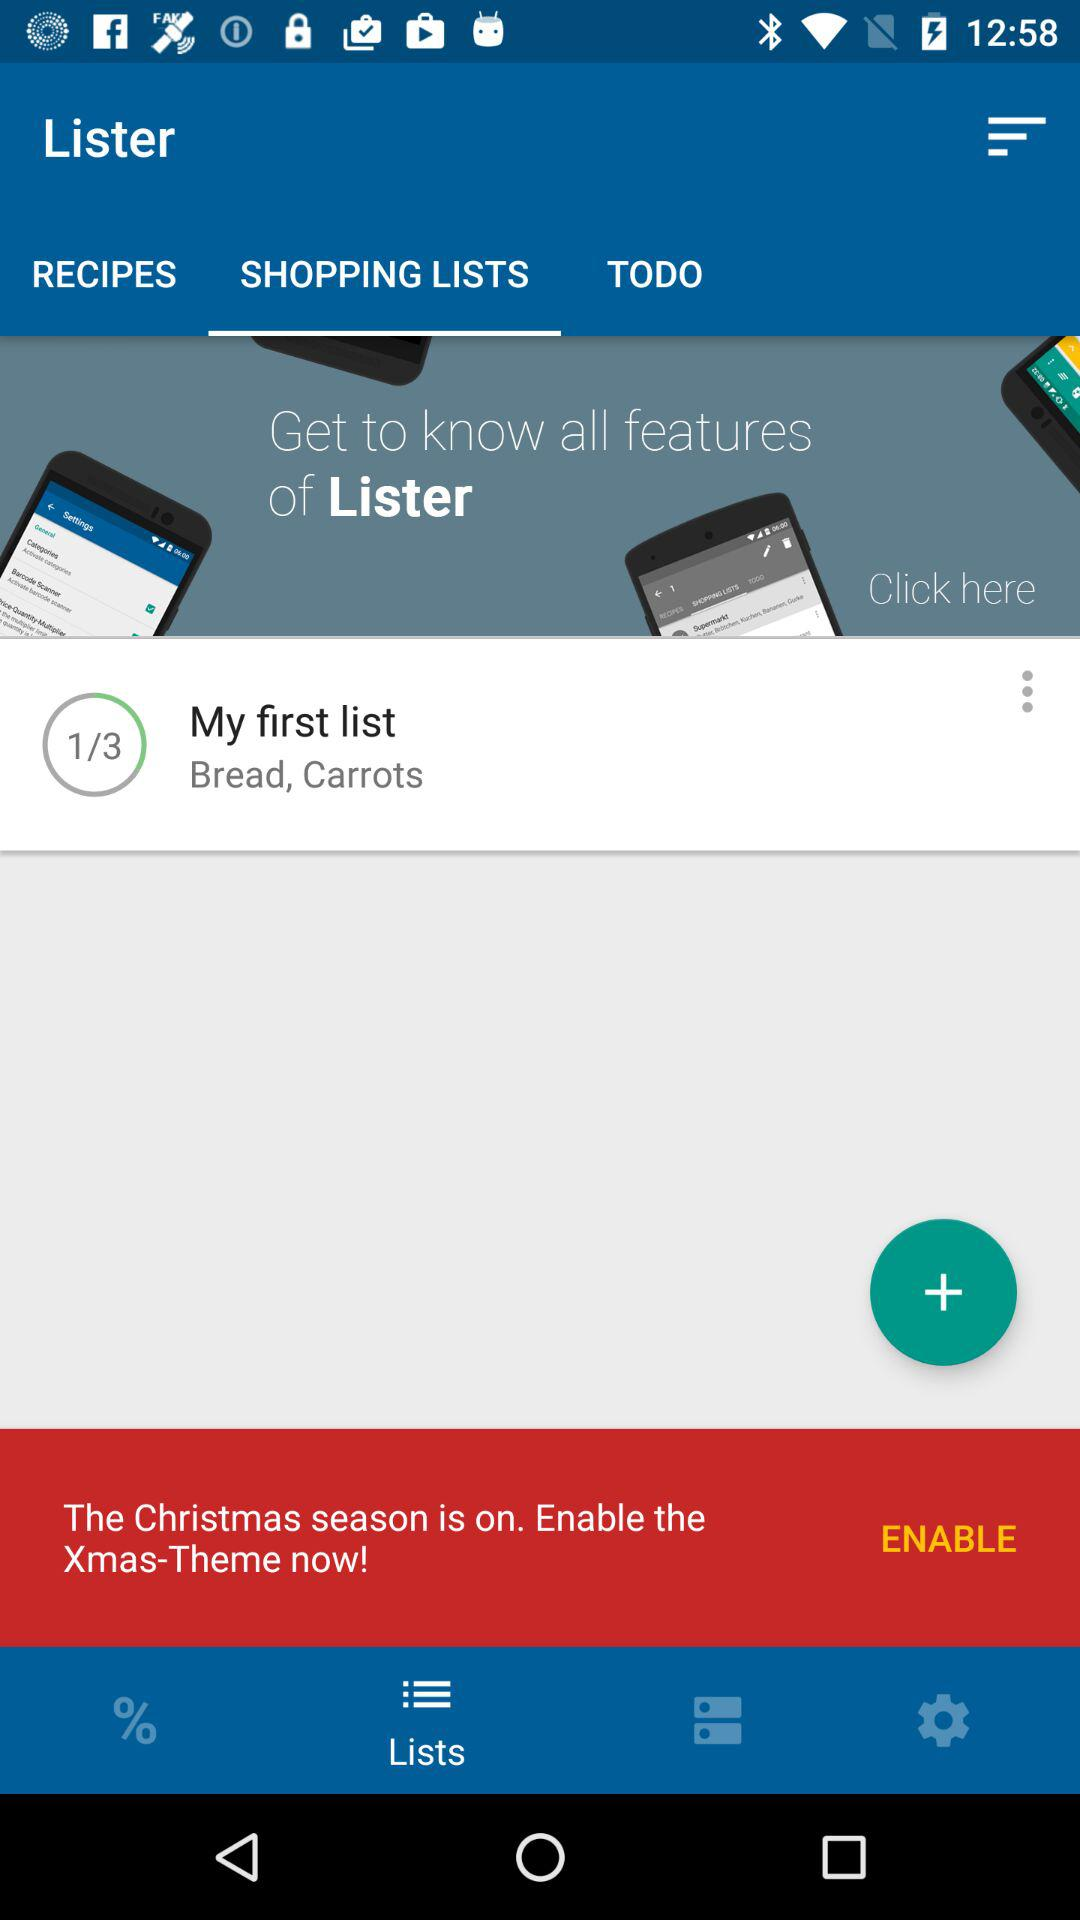How many pages are there in "My first list"? There are 3 pages. 